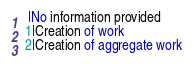<code> <loc_0><loc_0><loc_500><loc_500><_SQL_> |No information provided
1|Creation of work
2|Creation of aggregate work</code> 